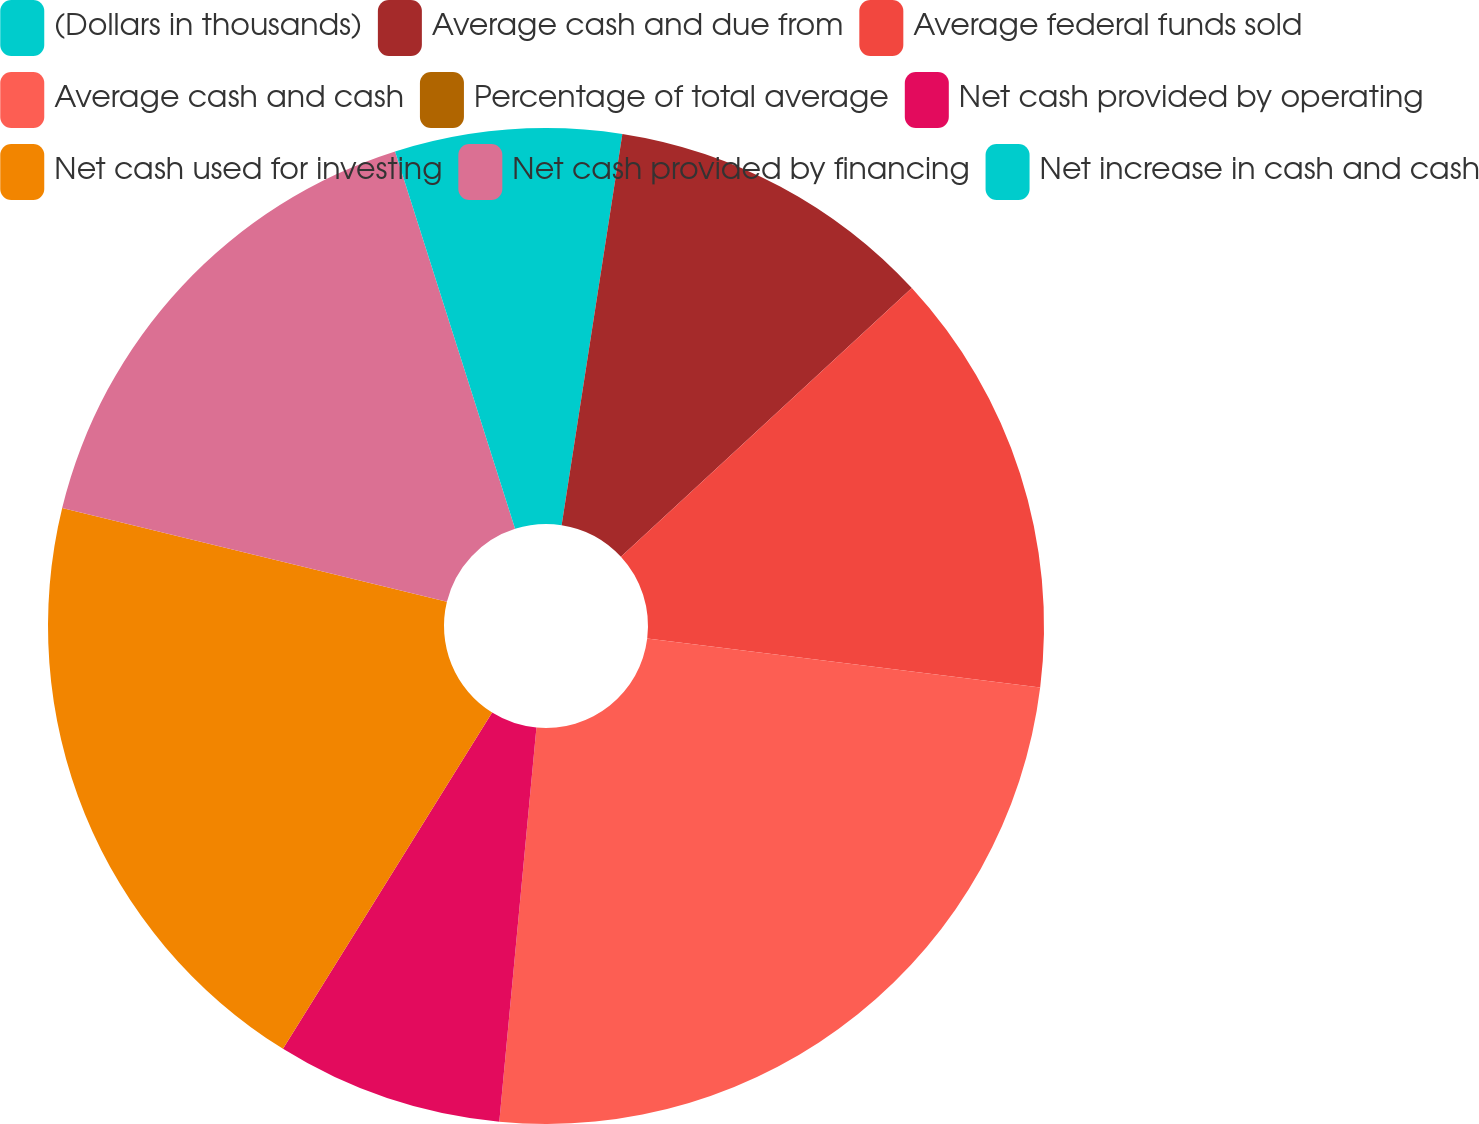Convert chart. <chart><loc_0><loc_0><loc_500><loc_500><pie_chart><fcel>(Dollars in thousands)<fcel>Average cash and due from<fcel>Average federal funds sold<fcel>Average cash and cash<fcel>Percentage of total average<fcel>Net cash provided by operating<fcel>Net cash used for investing<fcel>Net cash provided by financing<fcel>Net increase in cash and cash<nl><fcel>2.45%<fcel>10.68%<fcel>13.84%<fcel>24.52%<fcel>0.0%<fcel>7.36%<fcel>19.95%<fcel>16.29%<fcel>4.9%<nl></chart> 